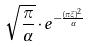<formula> <loc_0><loc_0><loc_500><loc_500>\sqrt { \frac { \pi } { \alpha } } \cdot e ^ { - \frac { ( \pi \xi ) ^ { 2 } } { \alpha } }</formula> 